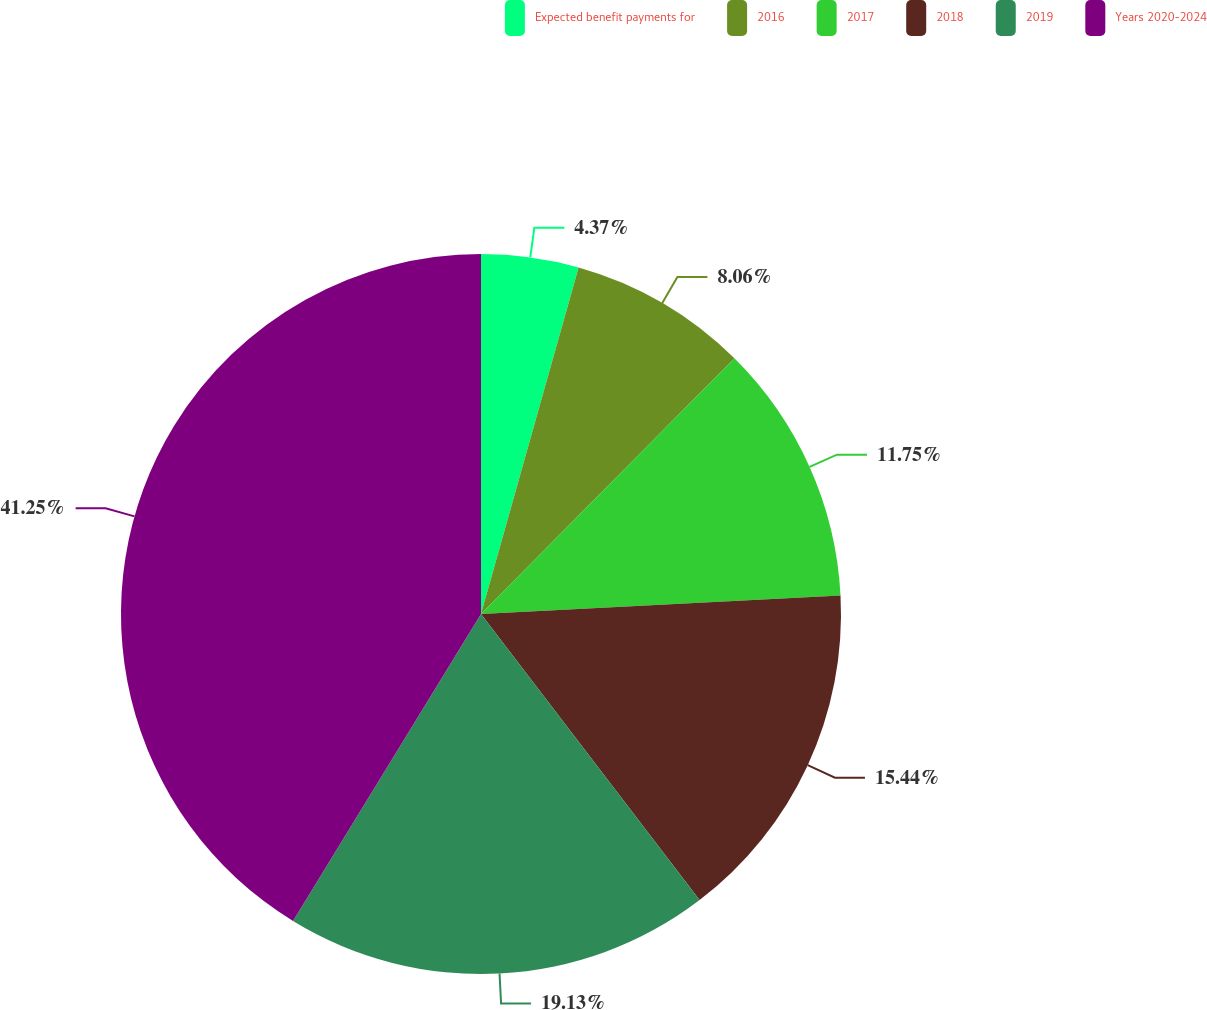Convert chart. <chart><loc_0><loc_0><loc_500><loc_500><pie_chart><fcel>Expected benefit payments for<fcel>2016<fcel>2017<fcel>2018<fcel>2019<fcel>Years 2020-2024<nl><fcel>4.37%<fcel>8.06%<fcel>11.75%<fcel>15.44%<fcel>19.13%<fcel>41.26%<nl></chart> 